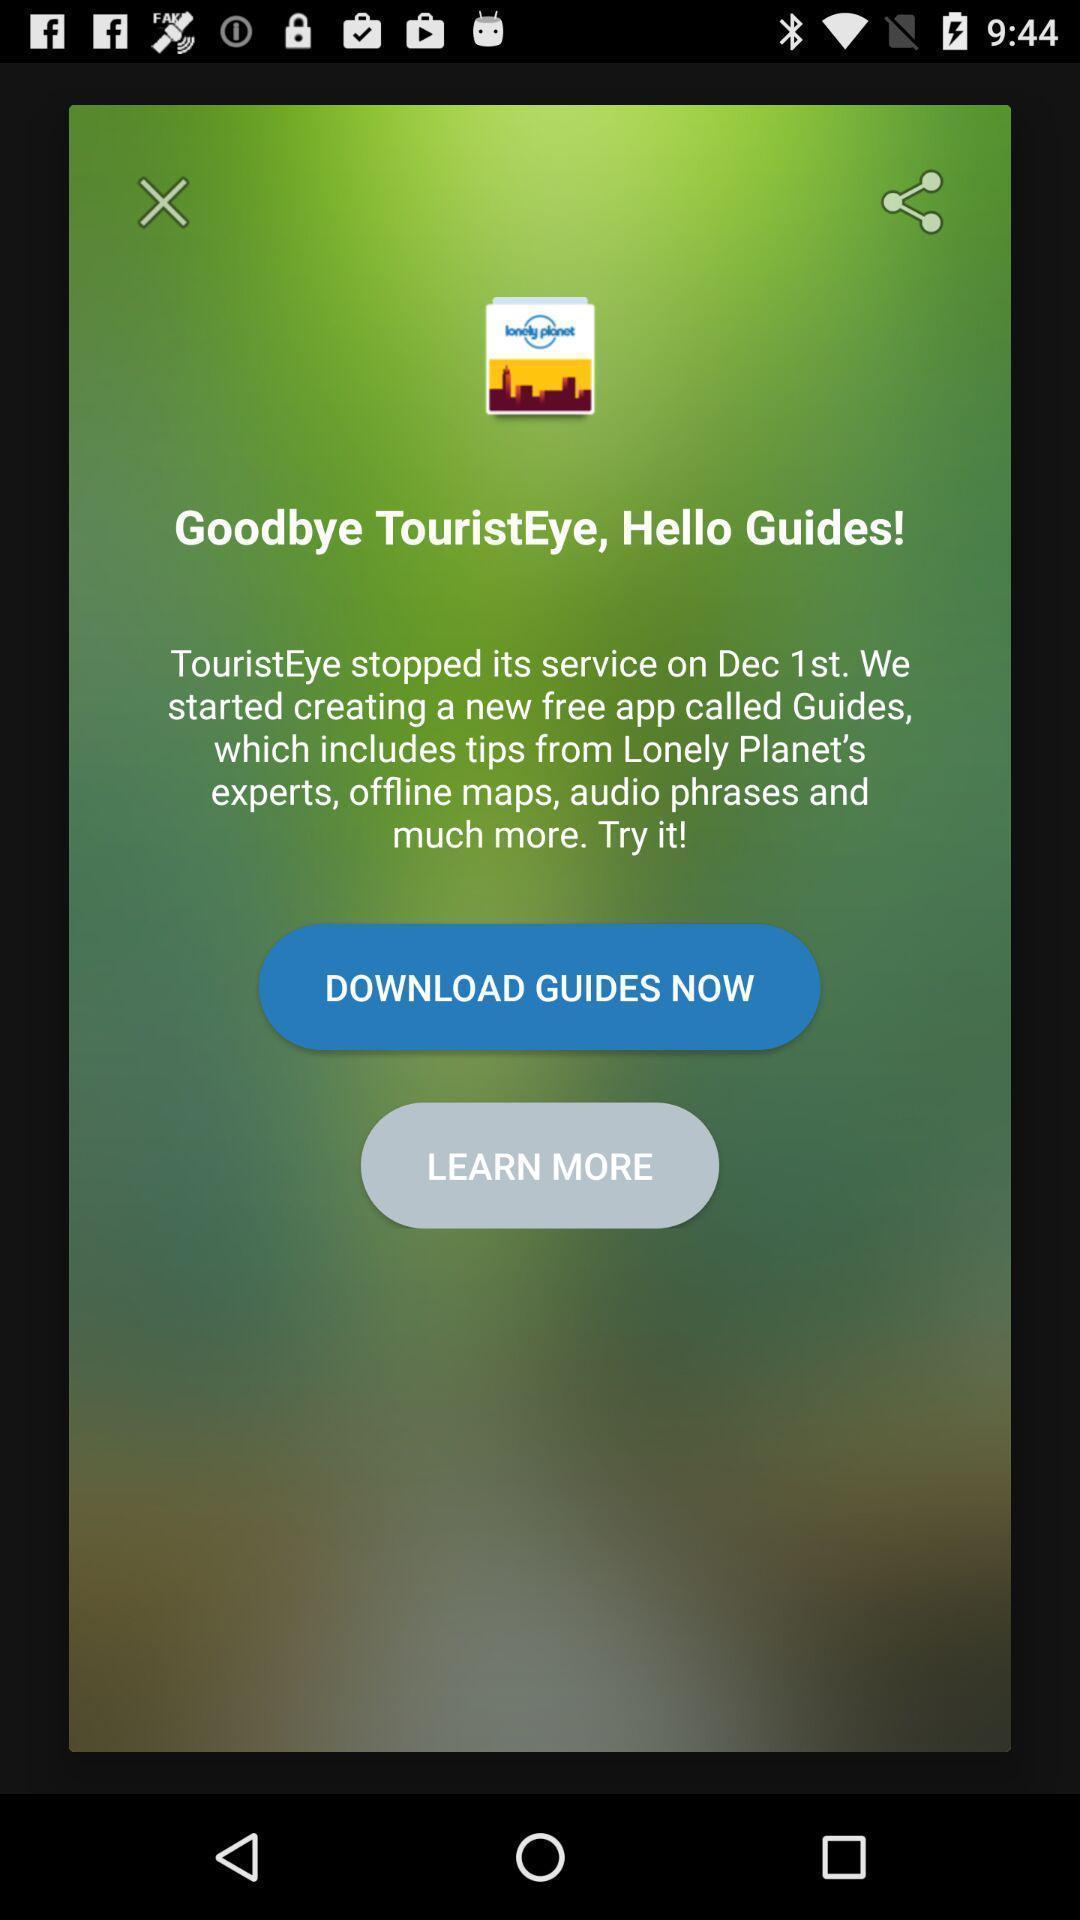Describe the content in this image. Pop-up to download the app. 